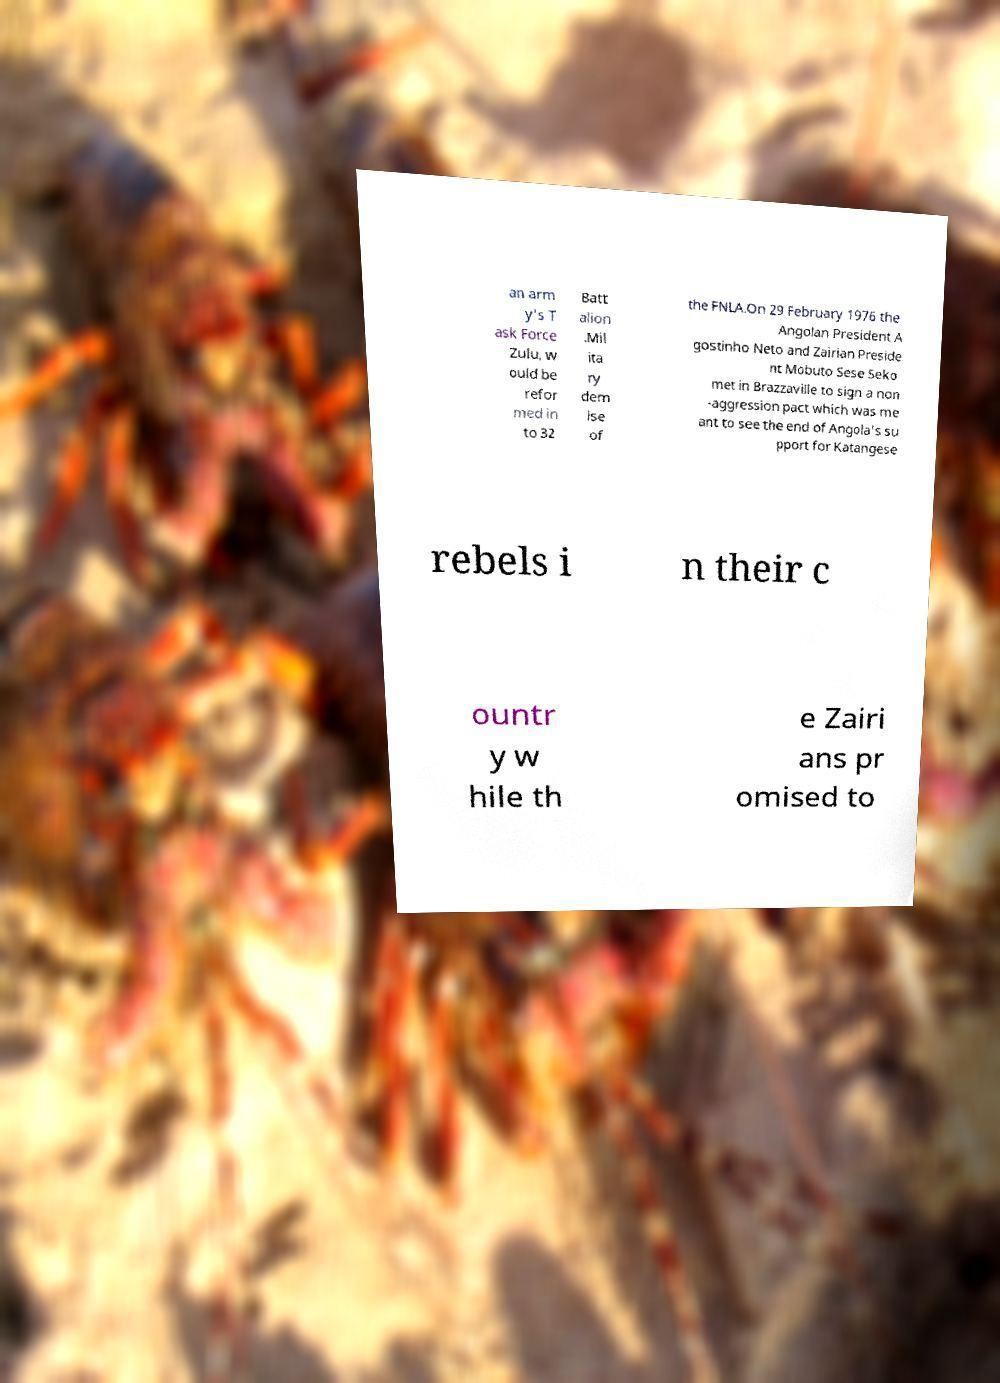Could you extract and type out the text from this image? an arm y's T ask Force Zulu, w ould be refor med in to 32 Batt alion .Mil ita ry dem ise of the FNLA.On 29 February 1976 the Angolan President A gostinho Neto and Zairian Preside nt Mobuto Sese Seko met in Brazzaville to sign a non -aggression pact which was me ant to see the end of Angola's su pport for Katangese rebels i n their c ountr y w hile th e Zairi ans pr omised to 